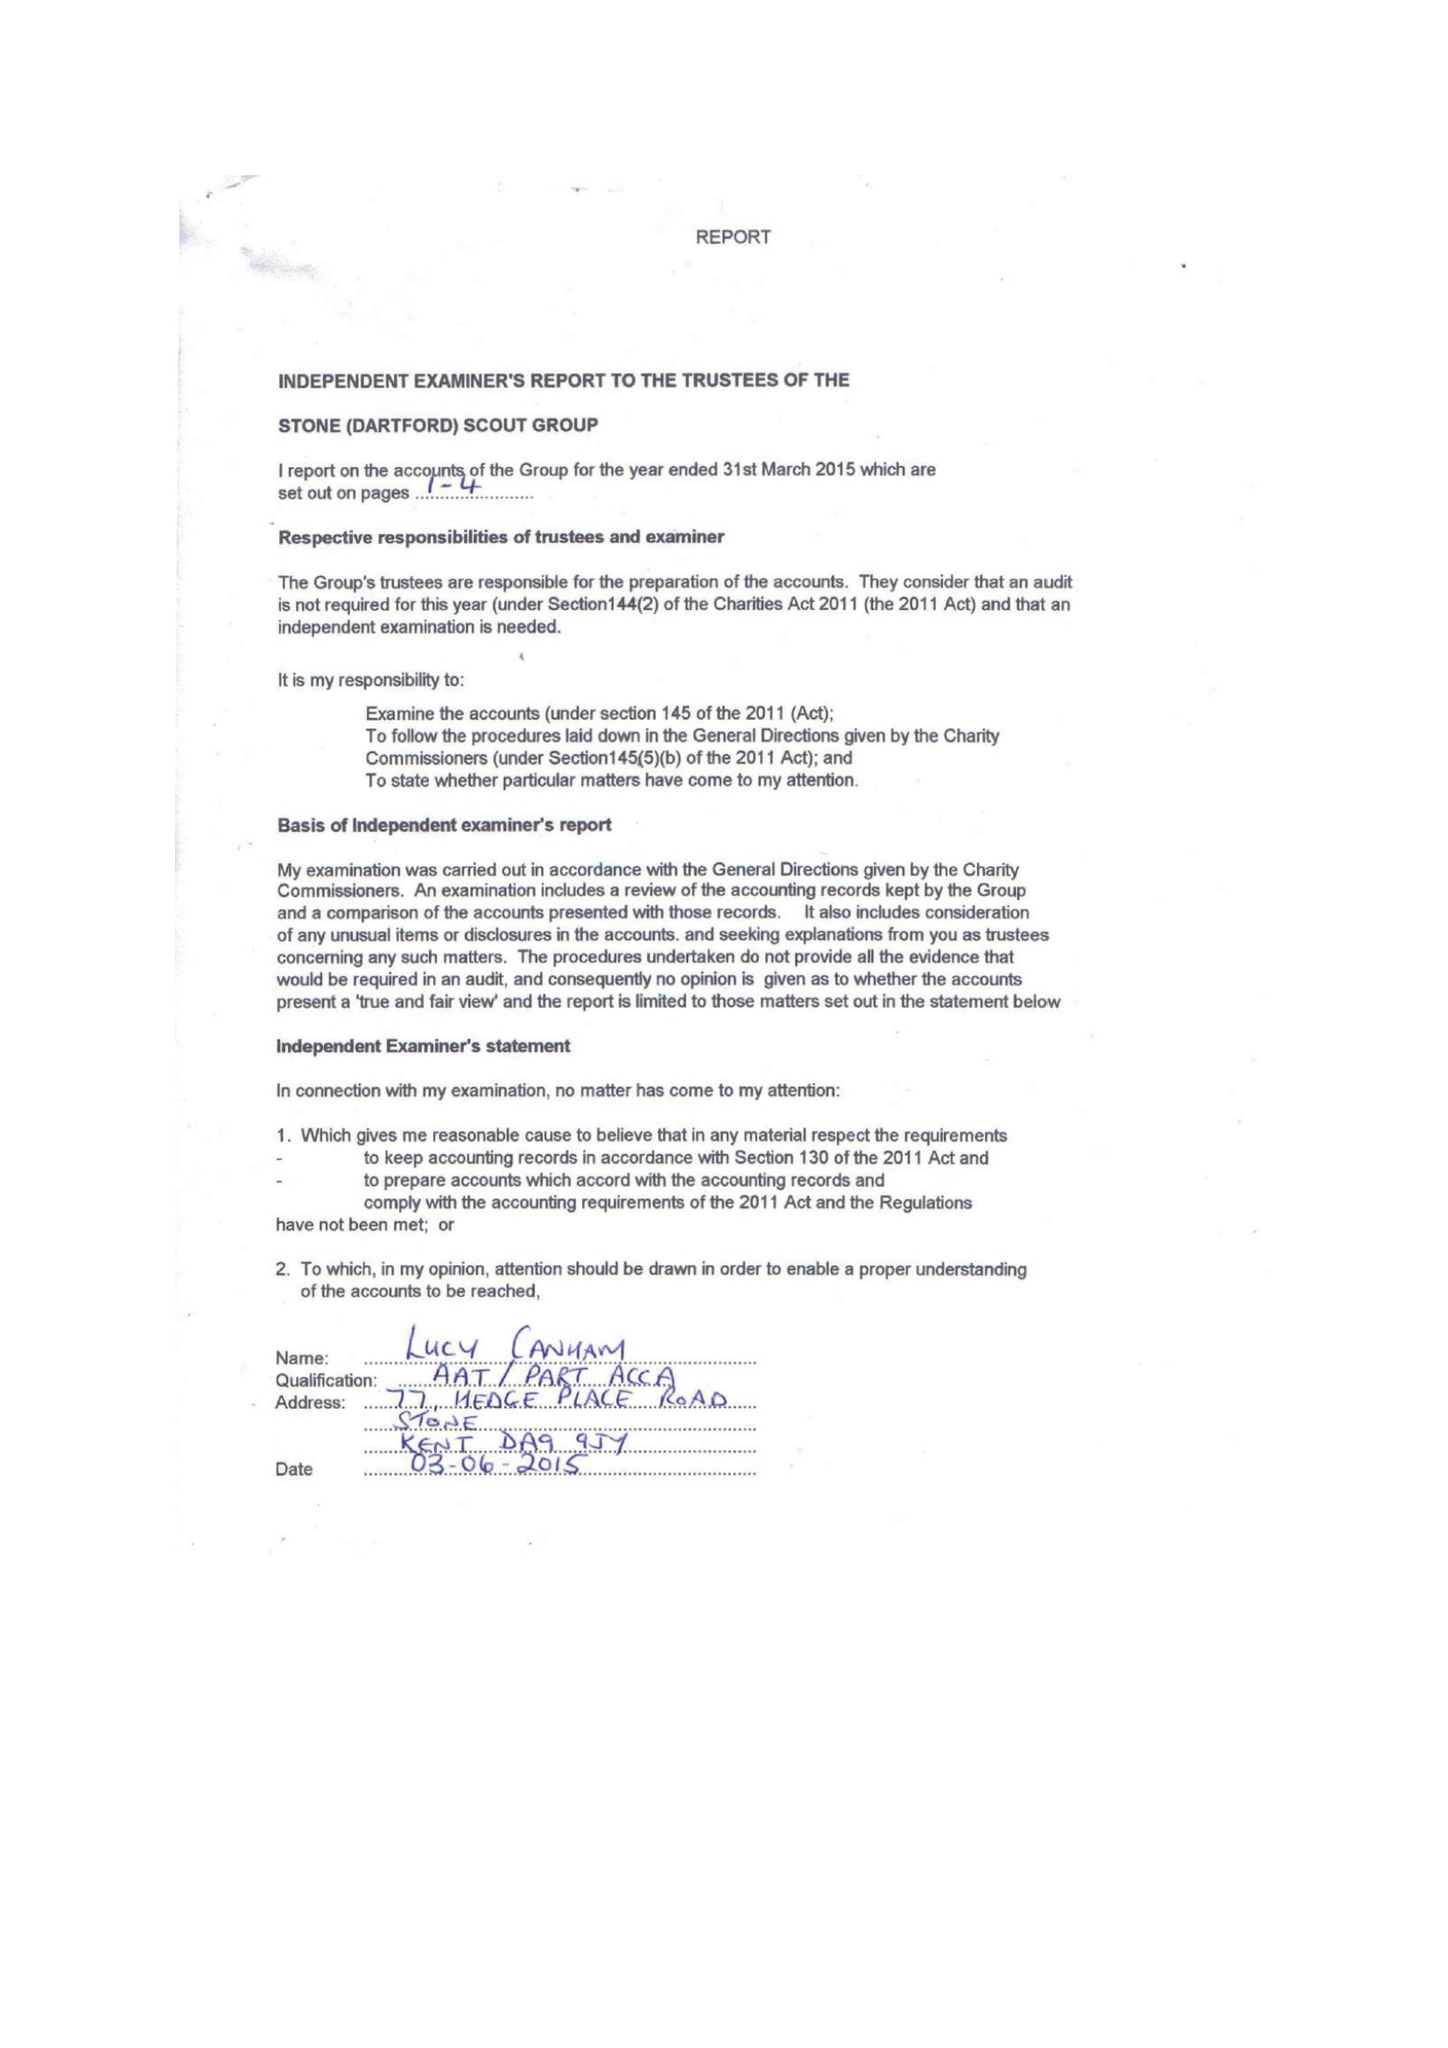What is the value for the charity_number?
Answer the question using a single word or phrase. 303451 